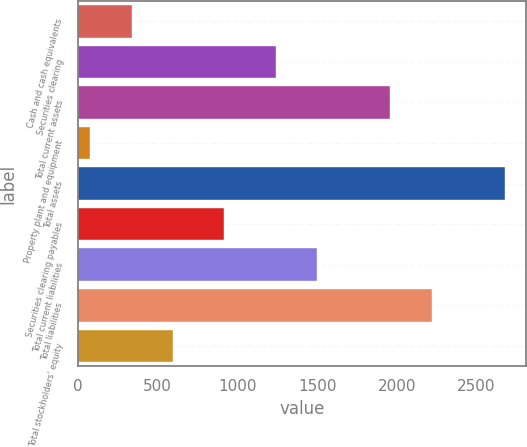<chart> <loc_0><loc_0><loc_500><loc_500><bar_chart><fcel>Cash and cash equivalents<fcel>Securities clearing<fcel>Total current assets<fcel>Property plant and equipment<fcel>Total assets<fcel>Securities clearing payables<fcel>Total current liabilities<fcel>Total liabilities<fcel>Total stockholders' equity<nl><fcel>337.48<fcel>1241.2<fcel>1960<fcel>77.4<fcel>2678.2<fcel>915.4<fcel>1501.28<fcel>2220.08<fcel>597.56<nl></chart> 